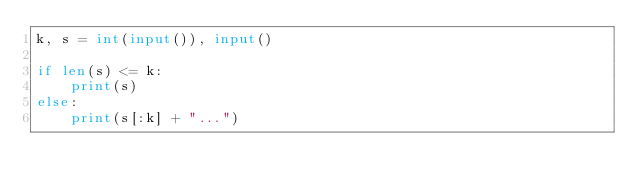Convert code to text. <code><loc_0><loc_0><loc_500><loc_500><_Python_>k, s = int(input()), input()

if len(s) <= k:
    print(s)
else:
    print(s[:k] + "...")</code> 